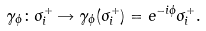<formula> <loc_0><loc_0><loc_500><loc_500>\gamma _ { \phi } \colon \sigma ^ { + } _ { i } \rightarrow \gamma _ { \phi } ( \sigma ^ { + } _ { i } ) = e ^ { - i \phi } \sigma ^ { + } _ { i } .</formula> 